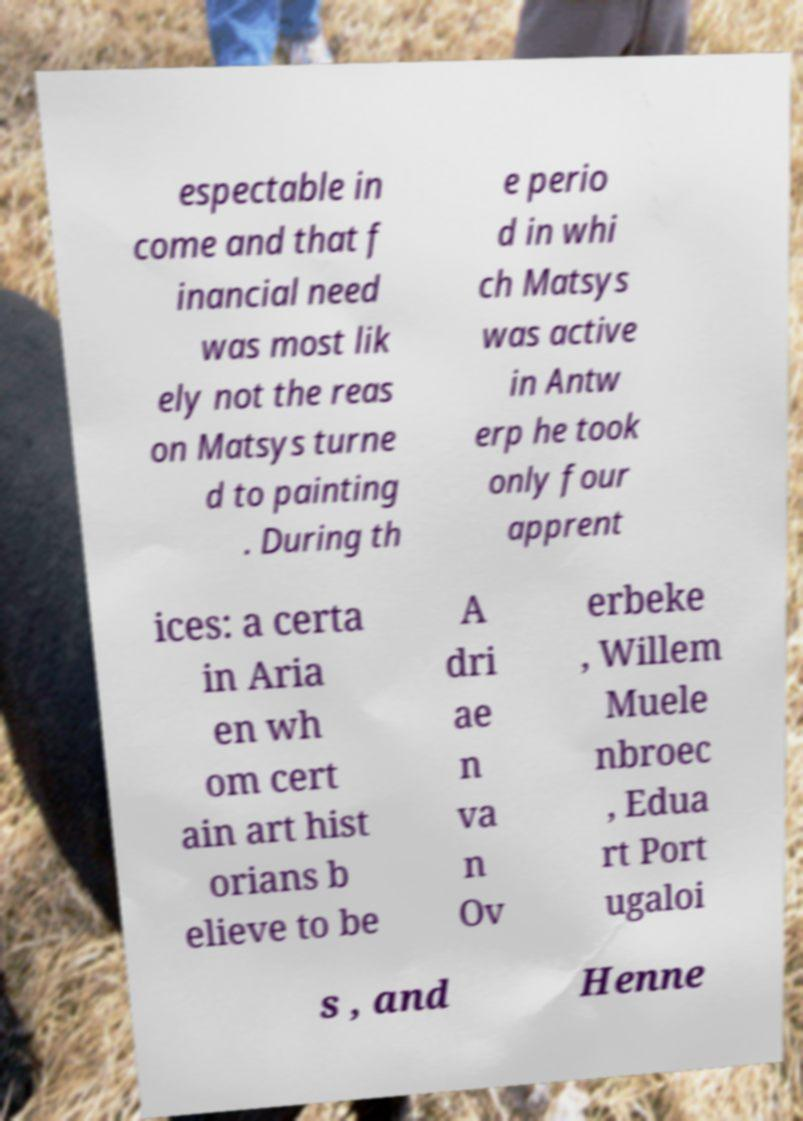Could you extract and type out the text from this image? espectable in come and that f inancial need was most lik ely not the reas on Matsys turne d to painting . During th e perio d in whi ch Matsys was active in Antw erp he took only four apprent ices: a certa in Aria en wh om cert ain art hist orians b elieve to be A dri ae n va n Ov erbeke , Willem Muele nbroec , Edua rt Port ugaloi s , and Henne 